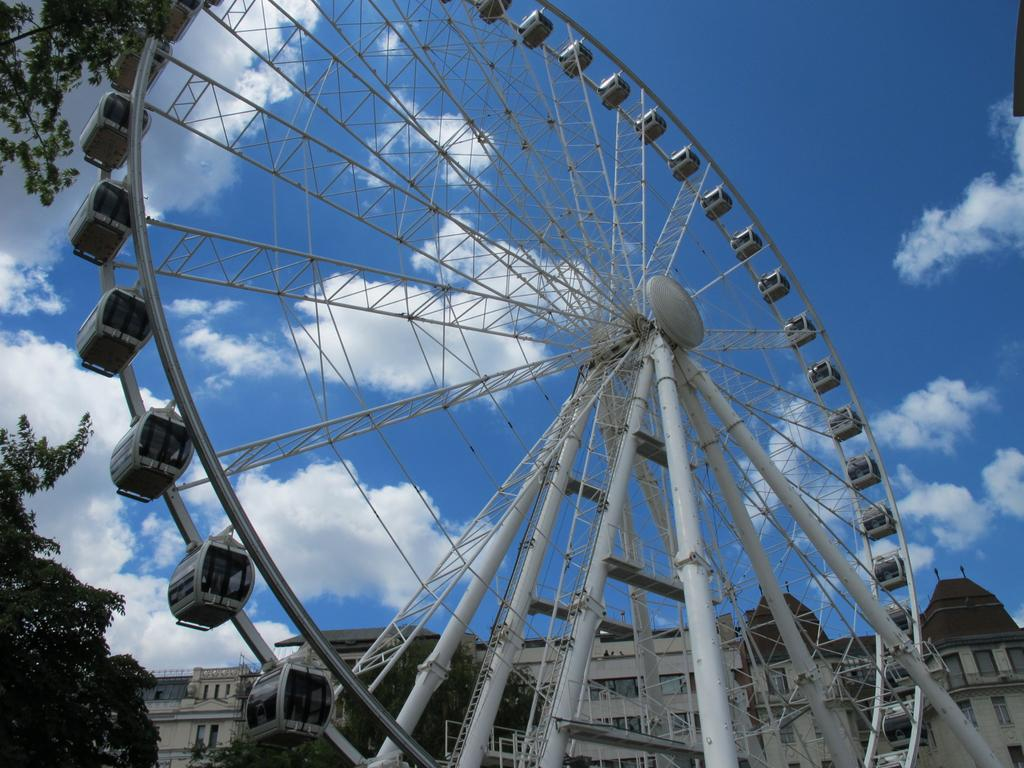What is the main subject in the image? There is a giant wheel in the image. What is the color of the giant wheel? The giant wheel is white in color. What can be seen on the left side of the image? There are leaves on the left side of the image. What is visible in the background of the image? There is a building in the background of the image. How would you describe the sky in the image? The sky is cloudy in the image. What advice does the cow give to the giant wheel in the image? There is no cow present in the image, so it is not possible to answer that question. 